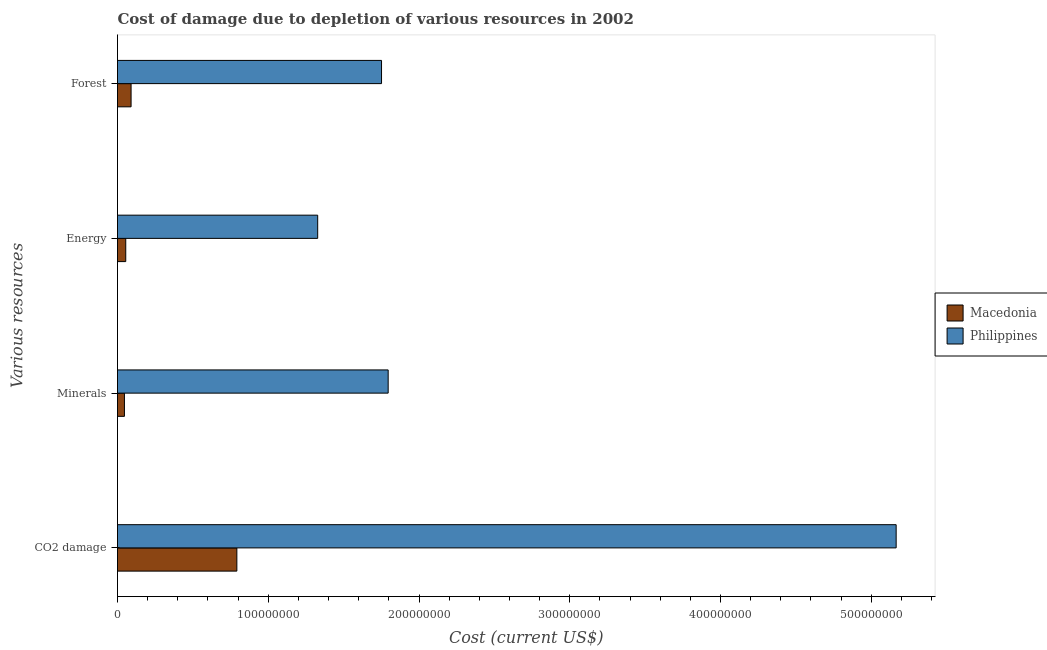How many different coloured bars are there?
Your response must be concise. 2. How many groups of bars are there?
Ensure brevity in your answer.  4. Are the number of bars on each tick of the Y-axis equal?
Make the answer very short. Yes. What is the label of the 1st group of bars from the top?
Ensure brevity in your answer.  Forest. What is the cost of damage due to depletion of energy in Philippines?
Ensure brevity in your answer.  1.33e+08. Across all countries, what is the maximum cost of damage due to depletion of forests?
Provide a short and direct response. 1.75e+08. Across all countries, what is the minimum cost of damage due to depletion of coal?
Your answer should be very brief. 7.92e+07. In which country was the cost of damage due to depletion of forests minimum?
Provide a short and direct response. Macedonia. What is the total cost of damage due to depletion of forests in the graph?
Offer a terse response. 1.84e+08. What is the difference between the cost of damage due to depletion of energy in Philippines and that in Macedonia?
Provide a short and direct response. 1.27e+08. What is the difference between the cost of damage due to depletion of energy in Macedonia and the cost of damage due to depletion of coal in Philippines?
Your answer should be very brief. -5.11e+08. What is the average cost of damage due to depletion of energy per country?
Provide a short and direct response. 6.91e+07. What is the difference between the cost of damage due to depletion of minerals and cost of damage due to depletion of coal in Macedonia?
Offer a very short reply. -7.46e+07. In how many countries, is the cost of damage due to depletion of minerals greater than 280000000 US$?
Ensure brevity in your answer.  0. What is the ratio of the cost of damage due to depletion of energy in Philippines to that in Macedonia?
Your answer should be very brief. 24.29. Is the cost of damage due to depletion of minerals in Philippines less than that in Macedonia?
Your response must be concise. No. Is the difference between the cost of damage due to depletion of minerals in Philippines and Macedonia greater than the difference between the cost of damage due to depletion of energy in Philippines and Macedonia?
Your answer should be compact. Yes. What is the difference between the highest and the second highest cost of damage due to depletion of coal?
Your answer should be very brief. 4.37e+08. What is the difference between the highest and the lowest cost of damage due to depletion of minerals?
Make the answer very short. 1.75e+08. What does the 1st bar from the top in Forest represents?
Your answer should be very brief. Philippines. What does the 1st bar from the bottom in Energy represents?
Your response must be concise. Macedonia. Is it the case that in every country, the sum of the cost of damage due to depletion of coal and cost of damage due to depletion of minerals is greater than the cost of damage due to depletion of energy?
Your answer should be compact. Yes. How many bars are there?
Offer a very short reply. 8. What is the difference between two consecutive major ticks on the X-axis?
Offer a terse response. 1.00e+08. Are the values on the major ticks of X-axis written in scientific E-notation?
Give a very brief answer. No. Does the graph contain any zero values?
Your answer should be compact. No. How many legend labels are there?
Keep it short and to the point. 2. How are the legend labels stacked?
Your answer should be compact. Vertical. What is the title of the graph?
Ensure brevity in your answer.  Cost of damage due to depletion of various resources in 2002 . Does "Middle income" appear as one of the legend labels in the graph?
Give a very brief answer. No. What is the label or title of the X-axis?
Offer a very short reply. Cost (current US$). What is the label or title of the Y-axis?
Provide a succinct answer. Various resources. What is the Cost (current US$) of Macedonia in CO2 damage?
Make the answer very short. 7.92e+07. What is the Cost (current US$) in Philippines in CO2 damage?
Offer a very short reply. 5.16e+08. What is the Cost (current US$) of Macedonia in Minerals?
Your answer should be compact. 4.60e+06. What is the Cost (current US$) in Philippines in Minerals?
Your answer should be compact. 1.80e+08. What is the Cost (current US$) in Macedonia in Energy?
Make the answer very short. 5.47e+06. What is the Cost (current US$) in Philippines in Energy?
Provide a short and direct response. 1.33e+08. What is the Cost (current US$) of Macedonia in Forest?
Your response must be concise. 9.01e+06. What is the Cost (current US$) of Philippines in Forest?
Offer a terse response. 1.75e+08. Across all Various resources, what is the maximum Cost (current US$) of Macedonia?
Your answer should be very brief. 7.92e+07. Across all Various resources, what is the maximum Cost (current US$) in Philippines?
Give a very brief answer. 5.16e+08. Across all Various resources, what is the minimum Cost (current US$) in Macedonia?
Provide a short and direct response. 4.60e+06. Across all Various resources, what is the minimum Cost (current US$) of Philippines?
Your answer should be compact. 1.33e+08. What is the total Cost (current US$) of Macedonia in the graph?
Offer a very short reply. 9.82e+07. What is the total Cost (current US$) in Philippines in the graph?
Provide a short and direct response. 1.00e+09. What is the difference between the Cost (current US$) of Macedonia in CO2 damage and that in Minerals?
Your response must be concise. 7.46e+07. What is the difference between the Cost (current US$) of Philippines in CO2 damage and that in Minerals?
Offer a very short reply. 3.37e+08. What is the difference between the Cost (current US$) in Macedonia in CO2 damage and that in Energy?
Make the answer very short. 7.37e+07. What is the difference between the Cost (current US$) of Philippines in CO2 damage and that in Energy?
Provide a succinct answer. 3.84e+08. What is the difference between the Cost (current US$) of Macedonia in CO2 damage and that in Forest?
Your response must be concise. 7.02e+07. What is the difference between the Cost (current US$) in Philippines in CO2 damage and that in Forest?
Your answer should be compact. 3.41e+08. What is the difference between the Cost (current US$) in Macedonia in Minerals and that in Energy?
Make the answer very short. -8.67e+05. What is the difference between the Cost (current US$) in Philippines in Minerals and that in Energy?
Keep it short and to the point. 4.67e+07. What is the difference between the Cost (current US$) of Macedonia in Minerals and that in Forest?
Offer a very short reply. -4.41e+06. What is the difference between the Cost (current US$) of Philippines in Minerals and that in Forest?
Offer a terse response. 4.40e+06. What is the difference between the Cost (current US$) in Macedonia in Energy and that in Forest?
Make the answer very short. -3.54e+06. What is the difference between the Cost (current US$) in Philippines in Energy and that in Forest?
Provide a succinct answer. -4.24e+07. What is the difference between the Cost (current US$) in Macedonia in CO2 damage and the Cost (current US$) in Philippines in Minerals?
Offer a very short reply. -1.00e+08. What is the difference between the Cost (current US$) of Macedonia in CO2 damage and the Cost (current US$) of Philippines in Energy?
Your answer should be compact. -5.36e+07. What is the difference between the Cost (current US$) in Macedonia in CO2 damage and the Cost (current US$) in Philippines in Forest?
Keep it short and to the point. -9.60e+07. What is the difference between the Cost (current US$) of Macedonia in Minerals and the Cost (current US$) of Philippines in Energy?
Make the answer very short. -1.28e+08. What is the difference between the Cost (current US$) in Macedonia in Minerals and the Cost (current US$) in Philippines in Forest?
Provide a succinct answer. -1.71e+08. What is the difference between the Cost (current US$) of Macedonia in Energy and the Cost (current US$) of Philippines in Forest?
Your answer should be very brief. -1.70e+08. What is the average Cost (current US$) in Macedonia per Various resources?
Your answer should be compact. 2.46e+07. What is the average Cost (current US$) of Philippines per Various resources?
Keep it short and to the point. 2.51e+08. What is the difference between the Cost (current US$) of Macedonia and Cost (current US$) of Philippines in CO2 damage?
Give a very brief answer. -4.37e+08. What is the difference between the Cost (current US$) of Macedonia and Cost (current US$) of Philippines in Minerals?
Your answer should be compact. -1.75e+08. What is the difference between the Cost (current US$) of Macedonia and Cost (current US$) of Philippines in Energy?
Offer a very short reply. -1.27e+08. What is the difference between the Cost (current US$) of Macedonia and Cost (current US$) of Philippines in Forest?
Make the answer very short. -1.66e+08. What is the ratio of the Cost (current US$) of Macedonia in CO2 damage to that in Minerals?
Your response must be concise. 17.21. What is the ratio of the Cost (current US$) in Philippines in CO2 damage to that in Minerals?
Your answer should be very brief. 2.88. What is the ratio of the Cost (current US$) in Macedonia in CO2 damage to that in Energy?
Offer a terse response. 14.48. What is the ratio of the Cost (current US$) of Philippines in CO2 damage to that in Energy?
Ensure brevity in your answer.  3.89. What is the ratio of the Cost (current US$) of Macedonia in CO2 damage to that in Forest?
Ensure brevity in your answer.  8.79. What is the ratio of the Cost (current US$) in Philippines in CO2 damage to that in Forest?
Your answer should be very brief. 2.95. What is the ratio of the Cost (current US$) of Macedonia in Minerals to that in Energy?
Keep it short and to the point. 0.84. What is the ratio of the Cost (current US$) of Philippines in Minerals to that in Energy?
Offer a very short reply. 1.35. What is the ratio of the Cost (current US$) of Macedonia in Minerals to that in Forest?
Offer a very short reply. 0.51. What is the ratio of the Cost (current US$) of Philippines in Minerals to that in Forest?
Ensure brevity in your answer.  1.03. What is the ratio of the Cost (current US$) of Macedonia in Energy to that in Forest?
Your response must be concise. 0.61. What is the ratio of the Cost (current US$) of Philippines in Energy to that in Forest?
Offer a very short reply. 0.76. What is the difference between the highest and the second highest Cost (current US$) of Macedonia?
Offer a very short reply. 7.02e+07. What is the difference between the highest and the second highest Cost (current US$) in Philippines?
Offer a very short reply. 3.37e+08. What is the difference between the highest and the lowest Cost (current US$) in Macedonia?
Your answer should be compact. 7.46e+07. What is the difference between the highest and the lowest Cost (current US$) of Philippines?
Provide a short and direct response. 3.84e+08. 